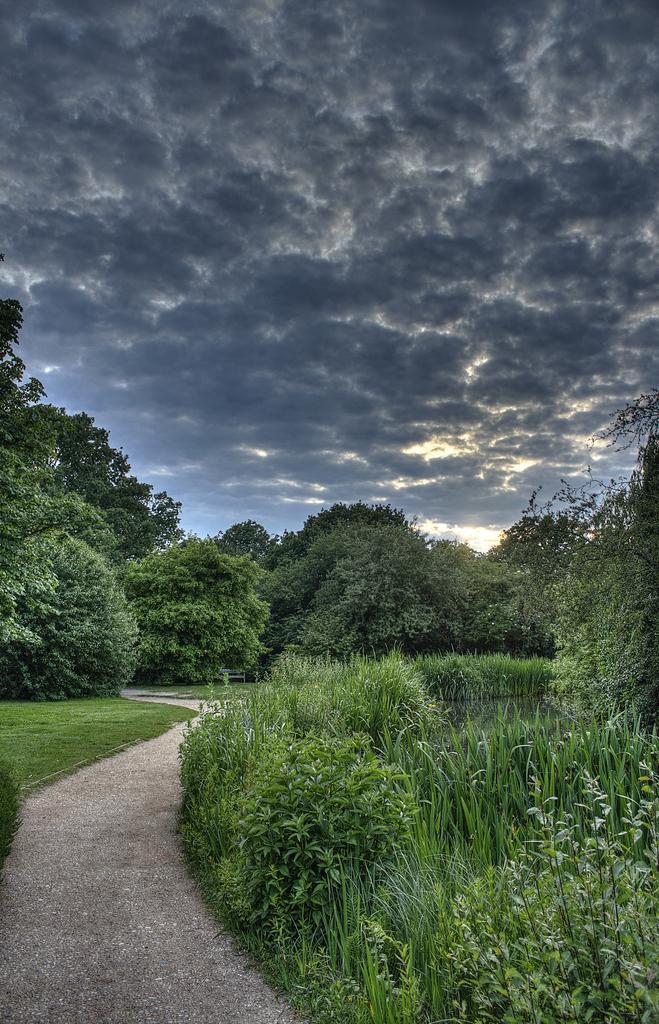Please provide a concise description of this image. There is a road. On both sides of this road, there is a grass, there are plants and trees. On the right side, there is a water. In the background, there are clouds in the sky. 